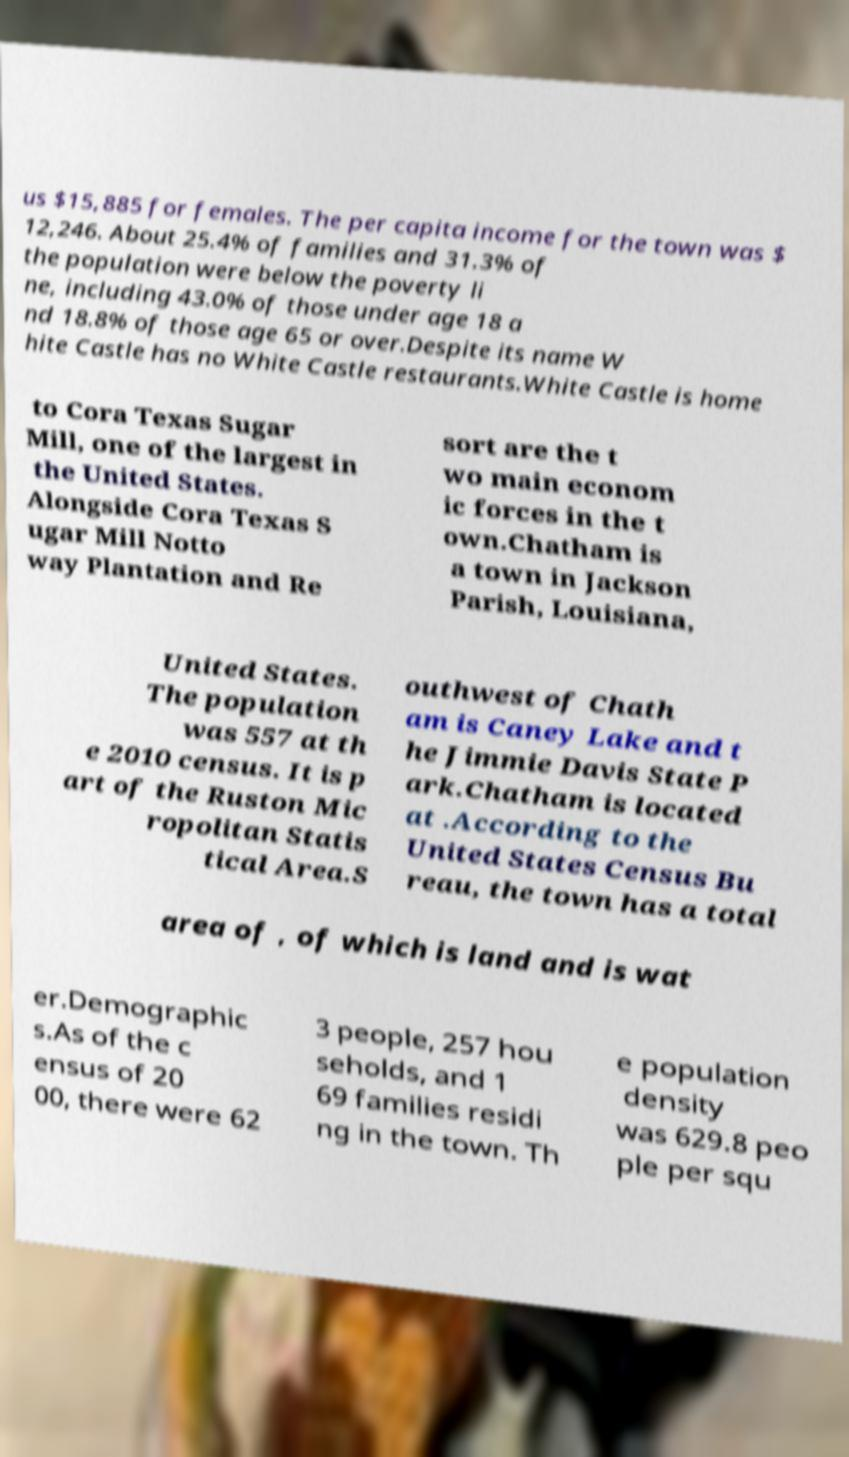What messages or text are displayed in this image? I need them in a readable, typed format. us $15,885 for females. The per capita income for the town was $ 12,246. About 25.4% of families and 31.3% of the population were below the poverty li ne, including 43.0% of those under age 18 a nd 18.8% of those age 65 or over.Despite its name W hite Castle has no White Castle restaurants.White Castle is home to Cora Texas Sugar Mill, one of the largest in the United States. Alongside Cora Texas S ugar Mill Notto way Plantation and Re sort are the t wo main econom ic forces in the t own.Chatham is a town in Jackson Parish, Louisiana, United States. The population was 557 at th e 2010 census. It is p art of the Ruston Mic ropolitan Statis tical Area.S outhwest of Chath am is Caney Lake and t he Jimmie Davis State P ark.Chatham is located at .According to the United States Census Bu reau, the town has a total area of , of which is land and is wat er.Demographic s.As of the c ensus of 20 00, there were 62 3 people, 257 hou seholds, and 1 69 families residi ng in the town. Th e population density was 629.8 peo ple per squ 